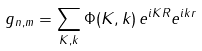Convert formula to latex. <formula><loc_0><loc_0><loc_500><loc_500>g _ { n , m } = \sum _ { K , k } \Phi ( K , k ) \, e ^ { i K R } e ^ { i k r }</formula> 